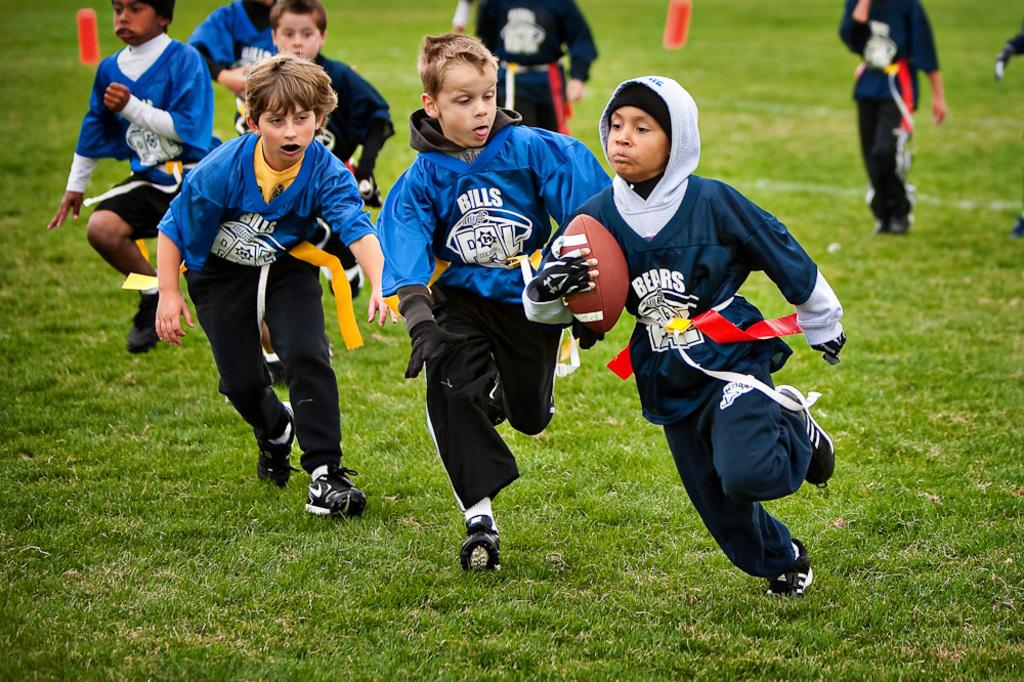Provide a one-sentence caption for the provided image. Kids playing football one is on the team bills and the other is on the bears. 